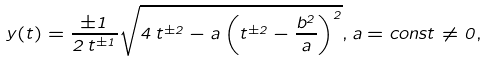<formula> <loc_0><loc_0><loc_500><loc_500>y ( t ) = \frac { \pm 1 } { 2 \, t ^ { \pm 1 } } \sqrt { 4 \, t ^ { \pm 2 } - a \left ( t ^ { \pm 2 } - \frac { b ^ { 2 } } { a } \right ) ^ { 2 } } , a = c o n s t \neq 0 ,</formula> 